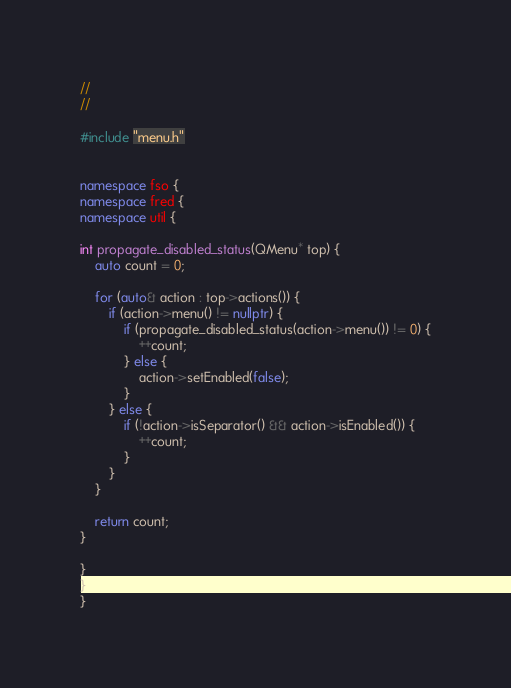Convert code to text. <code><loc_0><loc_0><loc_500><loc_500><_C++_>//
//

#include "menu.h"


namespace fso {
namespace fred {
namespace util {

int propagate_disabled_status(QMenu* top) {
	auto count = 0;

	for (auto& action : top->actions()) {
		if (action->menu() != nullptr) {
			if (propagate_disabled_status(action->menu()) != 0) {
				++count;
			} else {
				action->setEnabled(false);
			}
		} else {
			if (!action->isSeparator() && action->isEnabled()) {
				++count;
			}
		}
	}

	return count;
}

}
}
}
</code> 